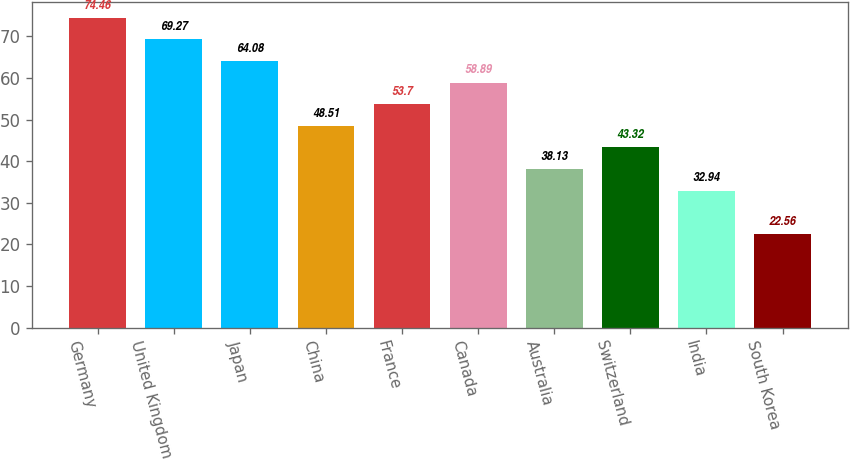<chart> <loc_0><loc_0><loc_500><loc_500><bar_chart><fcel>Germany<fcel>United Kingdom<fcel>Japan<fcel>China<fcel>France<fcel>Canada<fcel>Australia<fcel>Switzerland<fcel>India<fcel>South Korea<nl><fcel>74.46<fcel>69.27<fcel>64.08<fcel>48.51<fcel>53.7<fcel>58.89<fcel>38.13<fcel>43.32<fcel>32.94<fcel>22.56<nl></chart> 